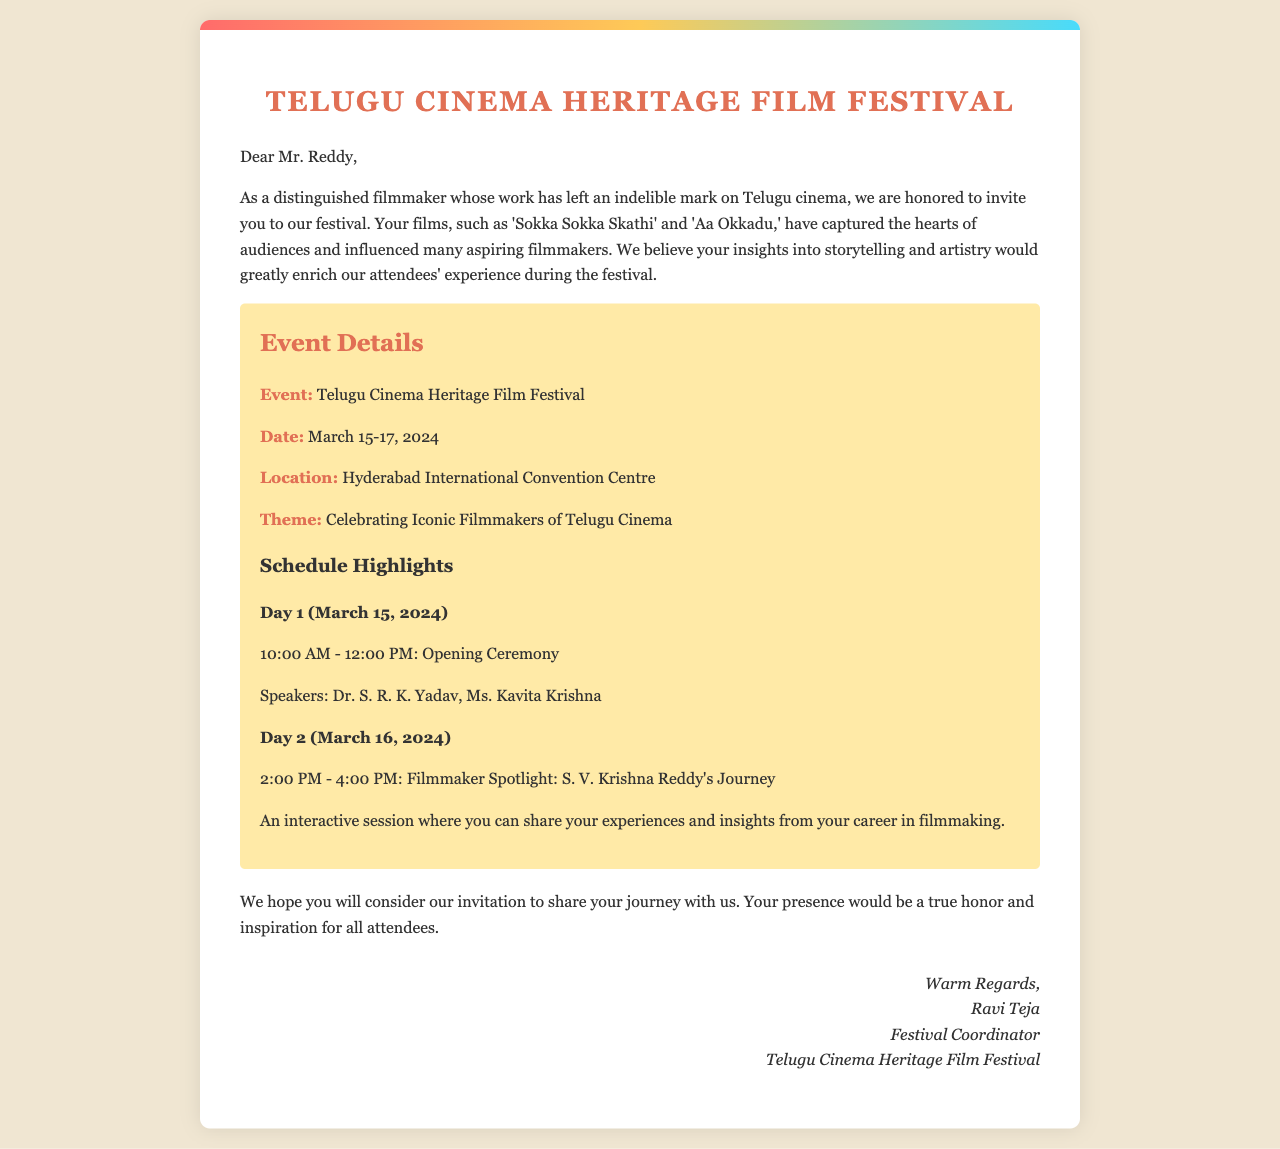What is the name of the film festival? The name of the film festival is mentioned in the title as "Telugu Cinema Heritage Film Festival."
Answer: Telugu Cinema Heritage Film Festival Who is invited to speak at the festival? The document mentions S. V. Krishna Reddy as the person who is invited to speak.
Answer: S. V. Krishna Reddy What are the dates of the event? The document states that the event will take place from March 15-17, 2024.
Answer: March 15-17, 2024 What is the theme of the festival? The theme is explicitly stated in the document as "Celebrating Iconic Filmmakers of Telugu Cinema."
Answer: Celebrating Iconic Filmmakers of Telugu Cinema What session is scheduled for March 16, 2024? The document describes the session on March 16 as "Filmmaker Spotlight: S. V. Krishna Reddy's Journey."
Answer: Filmmaker Spotlight: S. V. Krishna Reddy's Journey Who is the festival coordinator? The sign-off at the end of the letter reveals the festival coordinator's name as Ravi Teja.
Answer: Ravi Teja What time does the opening ceremony start? The schedule indicates that the opening ceremony starts at 10:00 AM.
Answer: 10:00 AM How many days does the festival last? The festival is scheduled to run for three days, as indicated by the dates provided.
Answer: Three days 